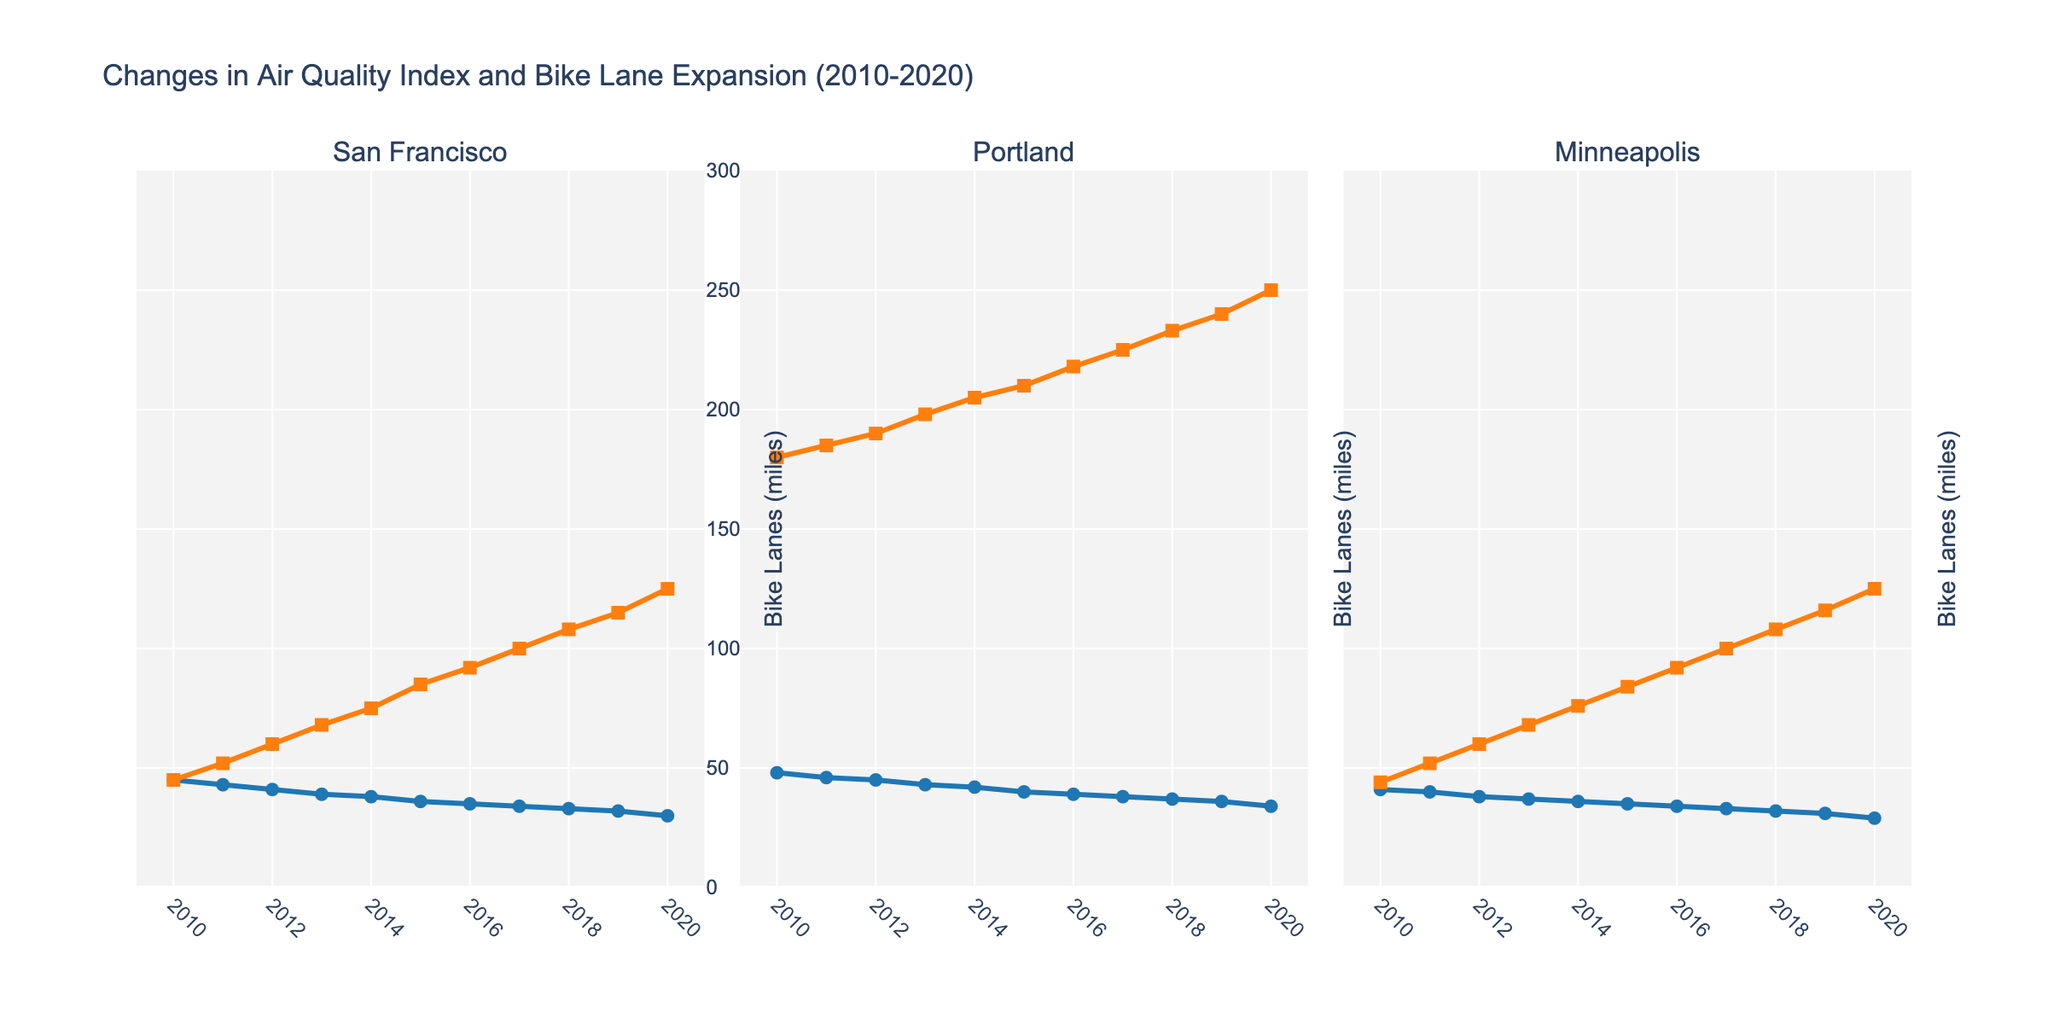What trend do you see in San Francisco's AQI from 2010 to 2020? The AQI in San Francisco decreases steadily from 45 in 2010 to 30 in 2020.
Answer: It decreases Compare the AQI trends of Portland and Minneapolis between 2015 and 2020. Which city saw a greater decrease? In 2015, Portland's AQI was 40, decreasing to 34 by 2020. Minneapolis's AQI was 35 in 2015, decreasing to 29 by 2020. Portland’s AQI decreased by 6 points, while Minneapolis’s decreased by 6 points.
Answer: Same decrease How many miles of bike lanes were added in Minneapolis from 2010 to 2015? In 2010, Minneapolis had 44 miles of bike lanes, and by 2015 it had 84 miles. So, the increase is 84 - 44 = 40 miles.
Answer: 40 miles By how much did San Francisco's AQI decrease per mile of new bike lanes added from 2010 to 2020? San Francisco's AQI decreased from 45 to 30 (a decrease of 15), while bike lanes increased from 45 to 125 miles (an increase of 80 miles). So the decrease per mile of new bike lanes is 15 / 80 = 0.1875.
Answer: 0.1875 per mile Which city had the highest number of bike lanes in 2020, and what was its corresponding AQI? In 2020, Portland had the highest number of bike lanes with 250 miles. Its corresponding AQI was 34.
Answer: Portland, 34 Between San Francisco and Portland, which city saw a larger relative reduction in AQI from 2010 to 2020? San Francisco's AQI dropped from 45 to 30, a relative reduction of (45-30)/45 = 0.3333 or 33.33%. Portland’s AQI dropped from 48 to 34, a relative reduction of (48-34)/48 = 0.2917 or 29.17%. San Francisco had a larger relative reduction.
Answer: San Francisco In which year did San Francisco and Minneapolis both have AQI lower than Portland's? In 2016, San Francisco’s AQI was 35, Minneapolis’s was 34, and Portland’s was 39.
Answer: 2016 Did the AQI values for Minneapolis show any trend of sudden spikes or drops from 2010 to 2020? The AQI values for Minneapolis show a steady decrease without any sudden spikes or drops.
Answer: No sudden spikes or drops Compare the overall trends in bike lane expansion from 2010 to 2020 in San Francisco and Portland. Both cities show a consistent increase in bike lane miles. San Francisco increased from 45 to 125 miles, and Portland from 180 to 250 miles. San Francisco has a more accelerated increase compared to Portland.
Answer: Similar trends, more accelerated in SF 